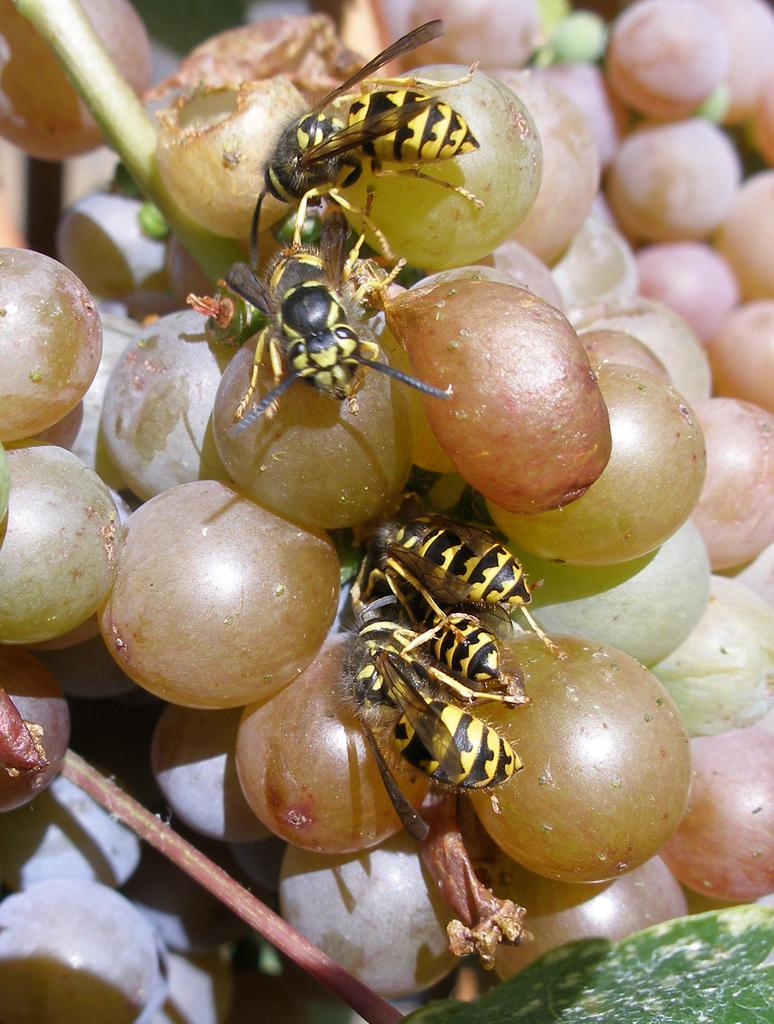What type of fruit can be seen in the image? There is a bunch of grapes in the image. What insects are present in the image? There are bees present in the image. What type of clouds can be seen in the image? There are no clouds visible in the image; it features a bunch of grapes and bees. What type of work is being done by the robin in the image? There is no robin present in the image. 